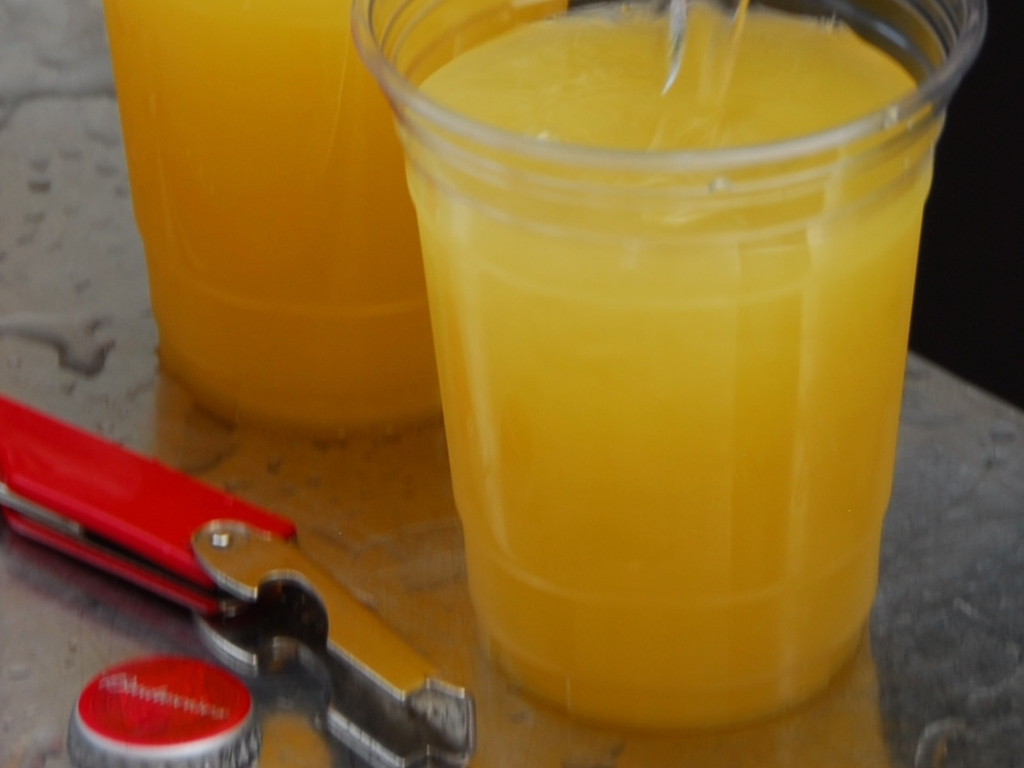What kind of beverage is shown in the image? The image depicts what appears to be orange juice in clear plastic cups. The bright color and context suggest a citrus-based drink, commonly served as a refreshing beverage. How can you tell it's orange juice? The vibrant orange color of the liquid is characteristic of orange juice. Additionally, the absence of pulp or seeds suggests it might be a strained or store-bought variety, rather than freshly squeezed with pulp. 